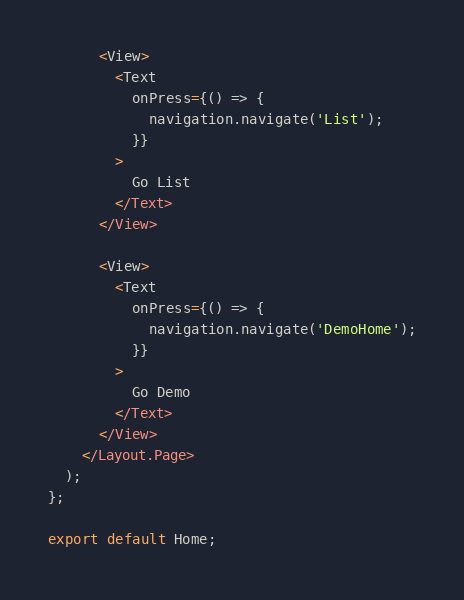<code> <loc_0><loc_0><loc_500><loc_500><_TypeScript_>
      <View>
        <Text
          onPress={() => {
            navigation.navigate('List');
          }}
        >
          Go List
        </Text>
      </View>

      <View>
        <Text
          onPress={() => {
            navigation.navigate('DemoHome');
          }}
        >
          Go Demo
        </Text>
      </View>
    </Layout.Page>
  );
};

export default Home;
</code> 